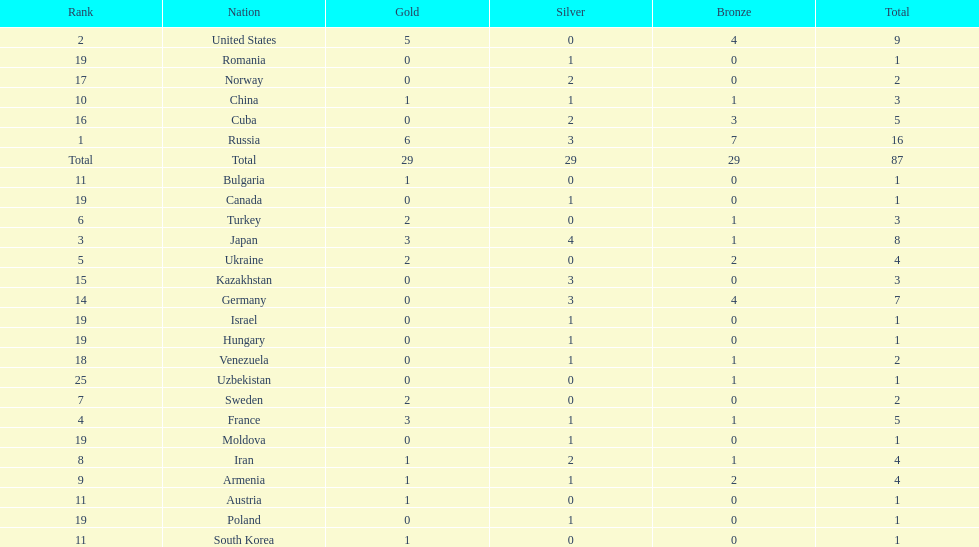What is the total amount of nations with more than 5 bronze medals? 1. 